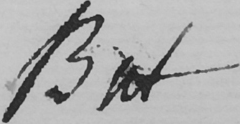Please provide the text content of this handwritten line. But 